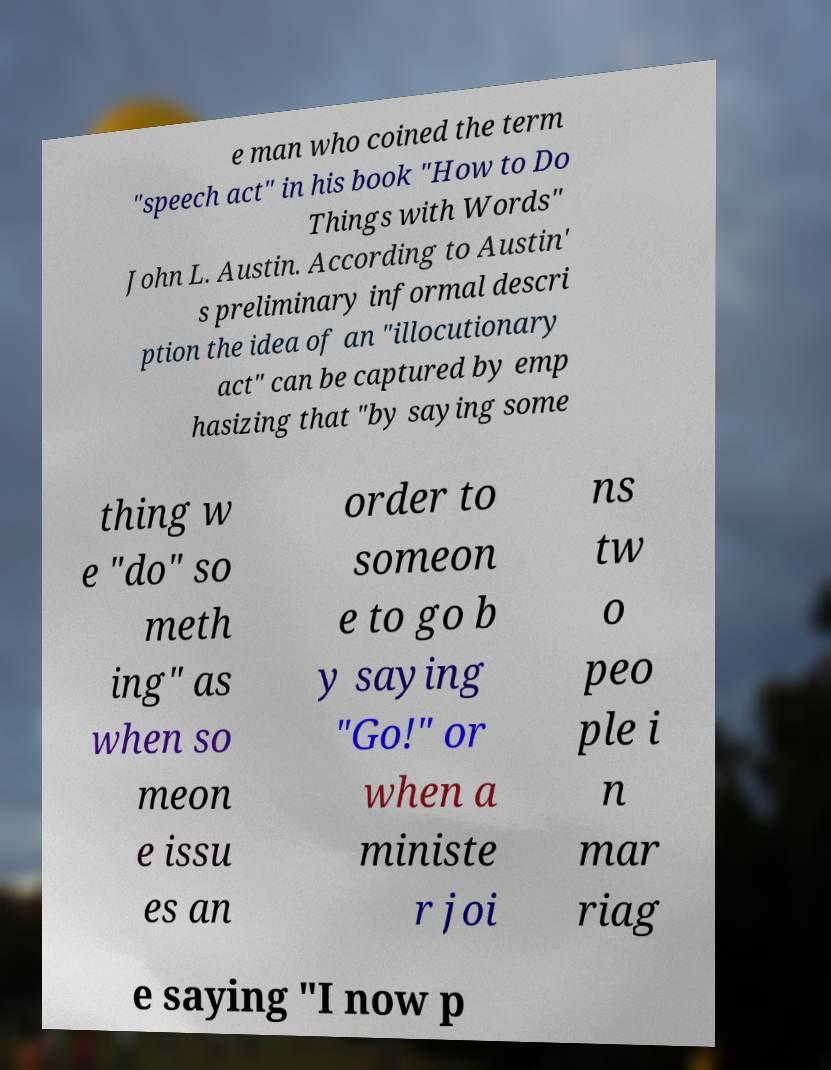Can you read and provide the text displayed in the image?This photo seems to have some interesting text. Can you extract and type it out for me? e man who coined the term "speech act" in his book "How to Do Things with Words" John L. Austin. According to Austin' s preliminary informal descri ption the idea of an "illocutionary act" can be captured by emp hasizing that "by saying some thing w e "do" so meth ing" as when so meon e issu es an order to someon e to go b y saying "Go!" or when a ministe r joi ns tw o peo ple i n mar riag e saying "I now p 